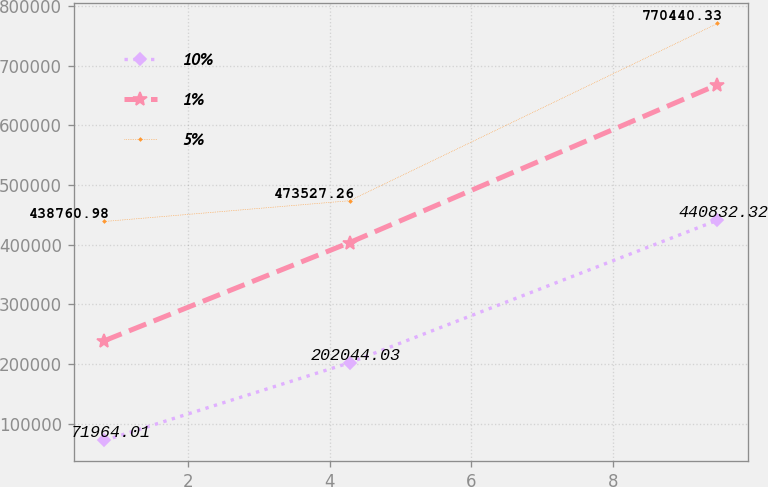Convert chart. <chart><loc_0><loc_0><loc_500><loc_500><line_chart><ecel><fcel>10%<fcel>1%<fcel>5%<nl><fcel>0.82<fcel>71964<fcel>239004<fcel>438761<nl><fcel>4.28<fcel>202044<fcel>403411<fcel>473527<nl><fcel>9.47<fcel>440832<fcel>667792<fcel>770440<nl></chart> 